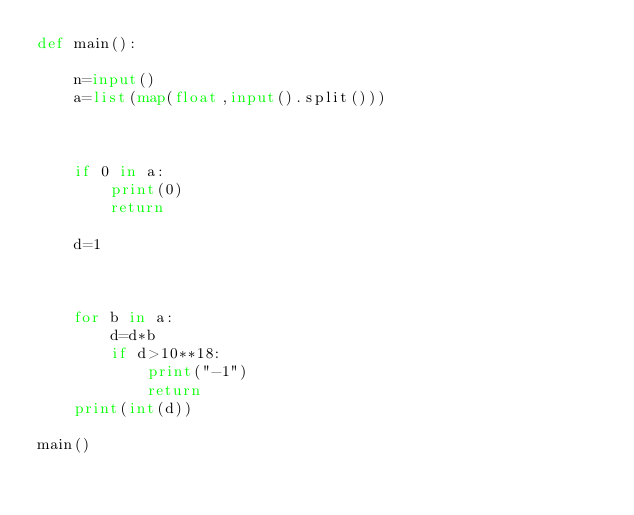Convert code to text. <code><loc_0><loc_0><loc_500><loc_500><_Python_>def main():

	n=input()
	a=list(map(float,input().split()))
    
	
	
	if 0 in a:
		print(0)
		return

	d=1
    
	

	for b in a:
		d=d*b
		if d>10**18:
			print("-1")
			return
	print(int(d))

main()</code> 